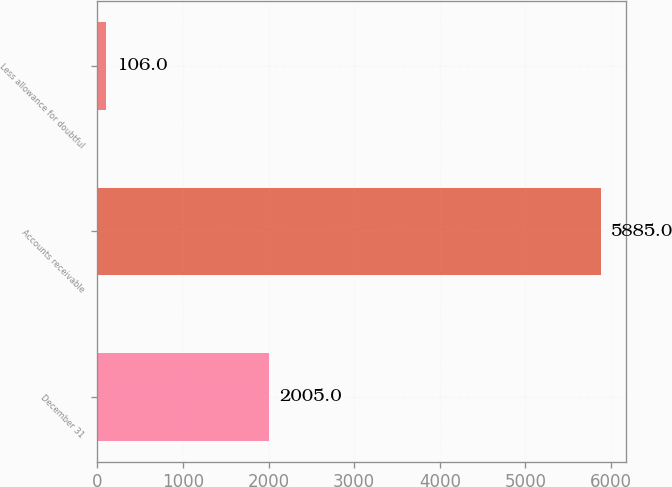Convert chart. <chart><loc_0><loc_0><loc_500><loc_500><bar_chart><fcel>December 31<fcel>Accounts receivable<fcel>Less allowance for doubtful<nl><fcel>2005<fcel>5885<fcel>106<nl></chart> 